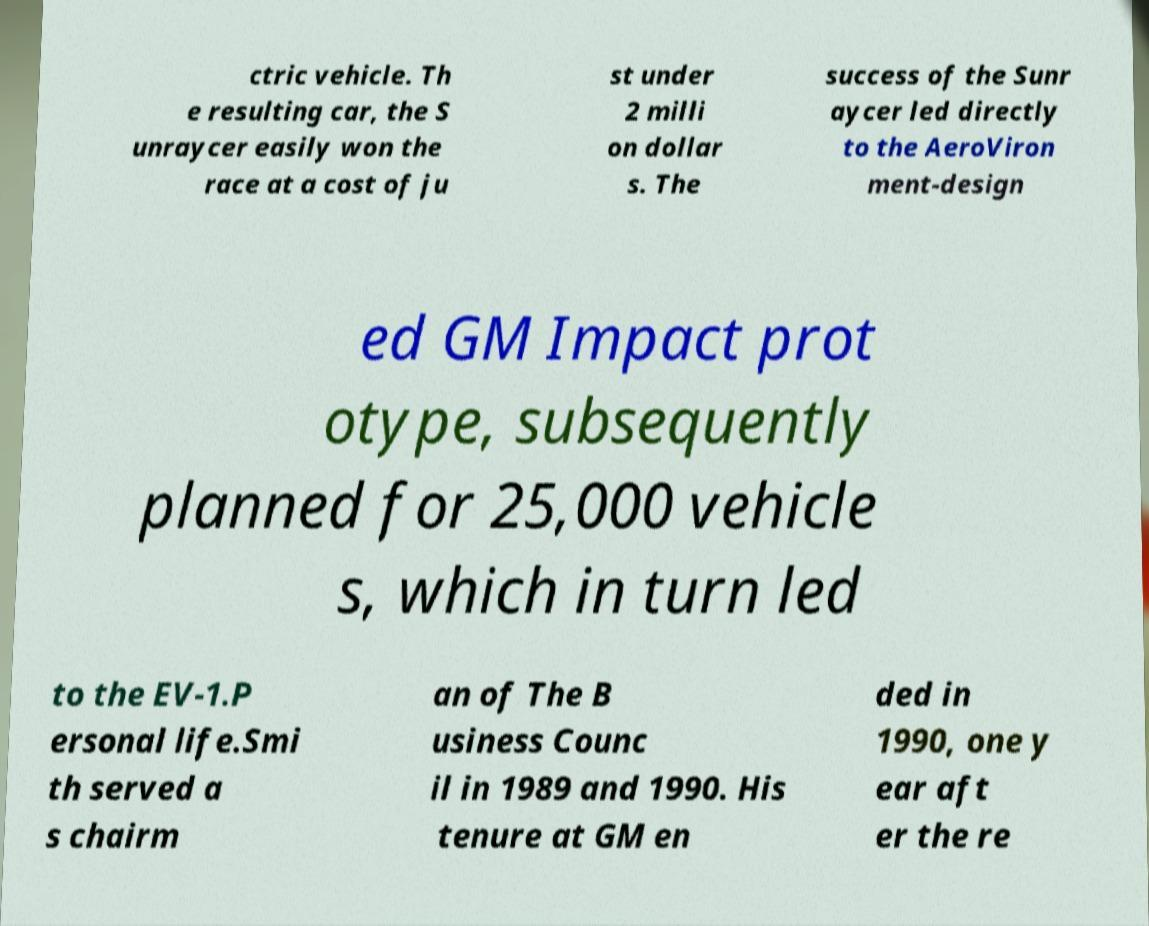I need the written content from this picture converted into text. Can you do that? ctric vehicle. Th e resulting car, the S unraycer easily won the race at a cost of ju st under 2 milli on dollar s. The success of the Sunr aycer led directly to the AeroViron ment-design ed GM Impact prot otype, subsequently planned for 25,000 vehicle s, which in turn led to the EV-1.P ersonal life.Smi th served a s chairm an of The B usiness Counc il in 1989 and 1990. His tenure at GM en ded in 1990, one y ear aft er the re 